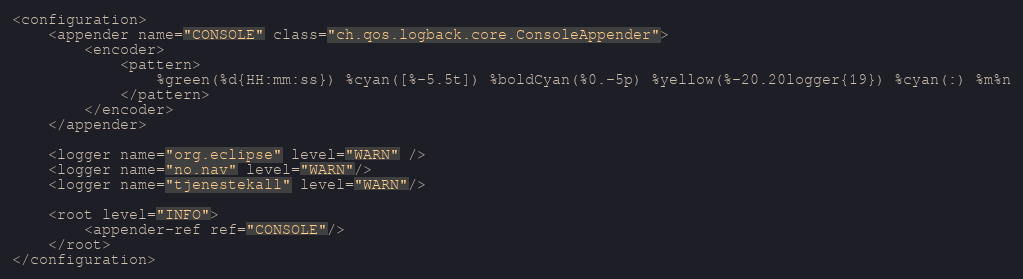Convert code to text. <code><loc_0><loc_0><loc_500><loc_500><_XML_><configuration>
    <appender name="CONSOLE" class="ch.qos.logback.core.ConsoleAppender">
        <encoder>
            <pattern>
                %green(%d{HH:mm:ss}) %cyan([%-5.5t]) %boldCyan(%0.-5p) %yellow(%-20.20logger{19}) %cyan(:) %m%n
            </pattern>
        </encoder>
    </appender>

    <logger name="org.eclipse" level="WARN" />
    <logger name="no.nav" level="WARN"/>
    <logger name="tjenestekall" level="WARN"/>

    <root level="INFO">
        <appender-ref ref="CONSOLE"/>
    </root>
</configuration>
</code> 